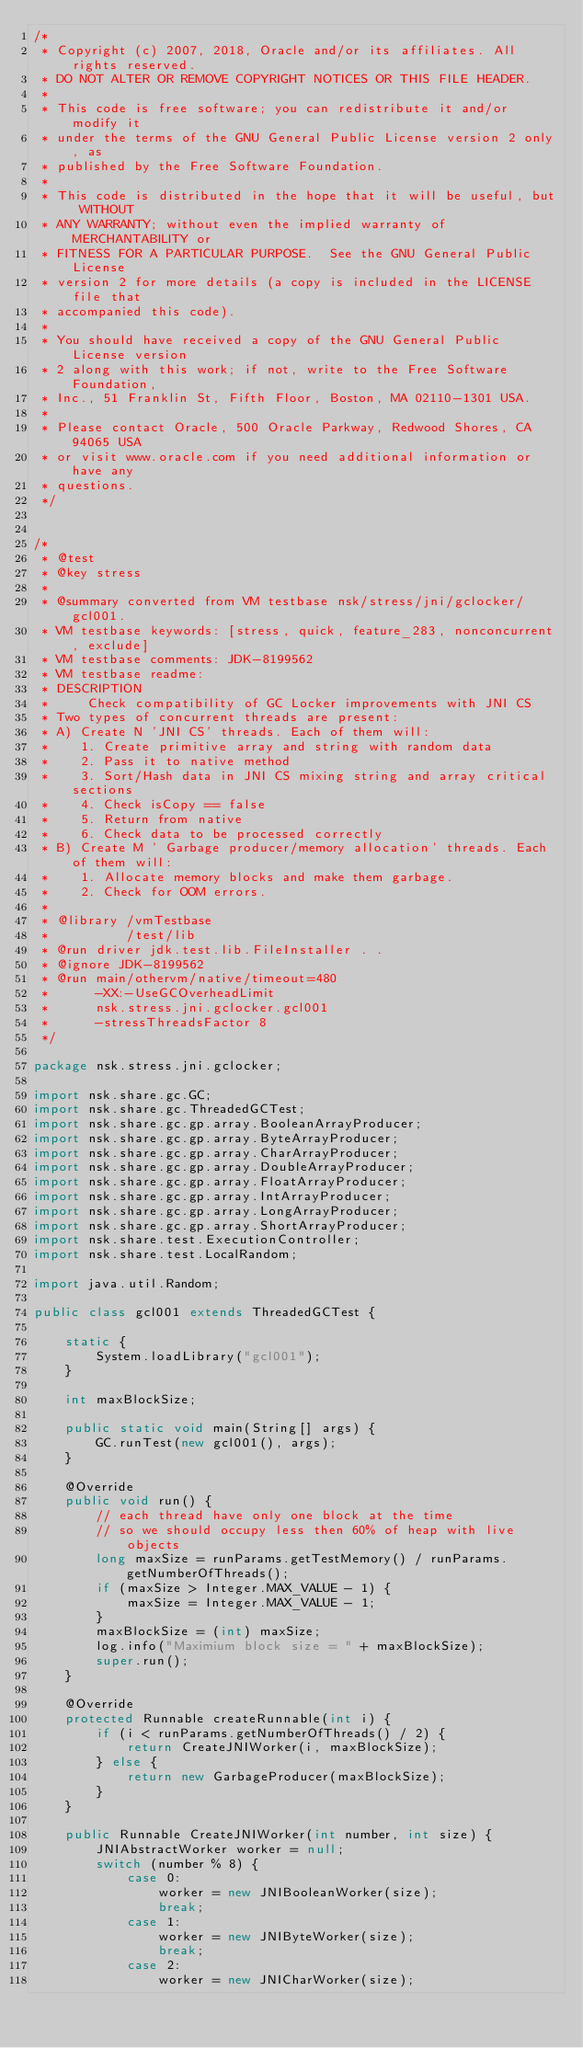<code> <loc_0><loc_0><loc_500><loc_500><_Java_>/*
 * Copyright (c) 2007, 2018, Oracle and/or its affiliates. All rights reserved.
 * DO NOT ALTER OR REMOVE COPYRIGHT NOTICES OR THIS FILE HEADER.
 *
 * This code is free software; you can redistribute it and/or modify it
 * under the terms of the GNU General Public License version 2 only, as
 * published by the Free Software Foundation.
 *
 * This code is distributed in the hope that it will be useful, but WITHOUT
 * ANY WARRANTY; without even the implied warranty of MERCHANTABILITY or
 * FITNESS FOR A PARTICULAR PURPOSE.  See the GNU General Public License
 * version 2 for more details (a copy is included in the LICENSE file that
 * accompanied this code).
 *
 * You should have received a copy of the GNU General Public License version
 * 2 along with this work; if not, write to the Free Software Foundation,
 * Inc., 51 Franklin St, Fifth Floor, Boston, MA 02110-1301 USA.
 *
 * Please contact Oracle, 500 Oracle Parkway, Redwood Shores, CA 94065 USA
 * or visit www.oracle.com if you need additional information or have any
 * questions.
 */


/*
 * @test
 * @key stress
 *
 * @summary converted from VM testbase nsk/stress/jni/gclocker/gcl001.
 * VM testbase keywords: [stress, quick, feature_283, nonconcurrent, exclude]
 * VM testbase comments: JDK-8199562
 * VM testbase readme:
 * DESCRIPTION
 *     Check compatibility of GC Locker improvements with JNI CS
 * Two types of concurrent threads are present:
 * A) Create N 'JNI CS' threads. Each of them will:
 *    1. Create primitive array and string with random data
 *    2. Pass it to native method
 *    3. Sort/Hash data in JNI CS mixing string and array critical sections
 *    4. Check isCopy == false
 *    5. Return from native
 *    6. Check data to be processed correctly
 * B) Create M ' Garbage producer/memory allocation' threads. Each of them will:
 *    1. Allocate memory blocks and make them garbage.
 *    2. Check for OOM errors.
 *
 * @library /vmTestbase
 *          /test/lib
 * @run driver jdk.test.lib.FileInstaller . .
 * @ignore JDK-8199562
 * @run main/othervm/native/timeout=480
 *      -XX:-UseGCOverheadLimit
 *      nsk.stress.jni.gclocker.gcl001
 *      -stressThreadsFactor 8
 */

package nsk.stress.jni.gclocker;

import nsk.share.gc.GC;
import nsk.share.gc.ThreadedGCTest;
import nsk.share.gc.gp.array.BooleanArrayProducer;
import nsk.share.gc.gp.array.ByteArrayProducer;
import nsk.share.gc.gp.array.CharArrayProducer;
import nsk.share.gc.gp.array.DoubleArrayProducer;
import nsk.share.gc.gp.array.FloatArrayProducer;
import nsk.share.gc.gp.array.IntArrayProducer;
import nsk.share.gc.gp.array.LongArrayProducer;
import nsk.share.gc.gp.array.ShortArrayProducer;
import nsk.share.test.ExecutionController;
import nsk.share.test.LocalRandom;

import java.util.Random;

public class gcl001 extends ThreadedGCTest {

    static {
        System.loadLibrary("gcl001");
    }

    int maxBlockSize;

    public static void main(String[] args) {
        GC.runTest(new gcl001(), args);
    }

    @Override
    public void run() {
        // each thread have only one block at the time
        // so we should occupy less then 60% of heap with live objects
        long maxSize = runParams.getTestMemory() / runParams.getNumberOfThreads();
        if (maxSize > Integer.MAX_VALUE - 1) {
            maxSize = Integer.MAX_VALUE - 1;
        }
        maxBlockSize = (int) maxSize;
        log.info("Maximium block size = " + maxBlockSize);
        super.run();
    }

    @Override
    protected Runnable createRunnable(int i) {
        if (i < runParams.getNumberOfThreads() / 2) {
            return CreateJNIWorker(i, maxBlockSize);
        } else {
            return new GarbageProducer(maxBlockSize);
        }
    }

    public Runnable CreateJNIWorker(int number, int size) {
        JNIAbstractWorker worker = null;
        switch (number % 8) {
            case 0:
                worker = new JNIBooleanWorker(size);
                break;
            case 1:
                worker = new JNIByteWorker(size);
                break;
            case 2:
                worker = new JNICharWorker(size);</code> 